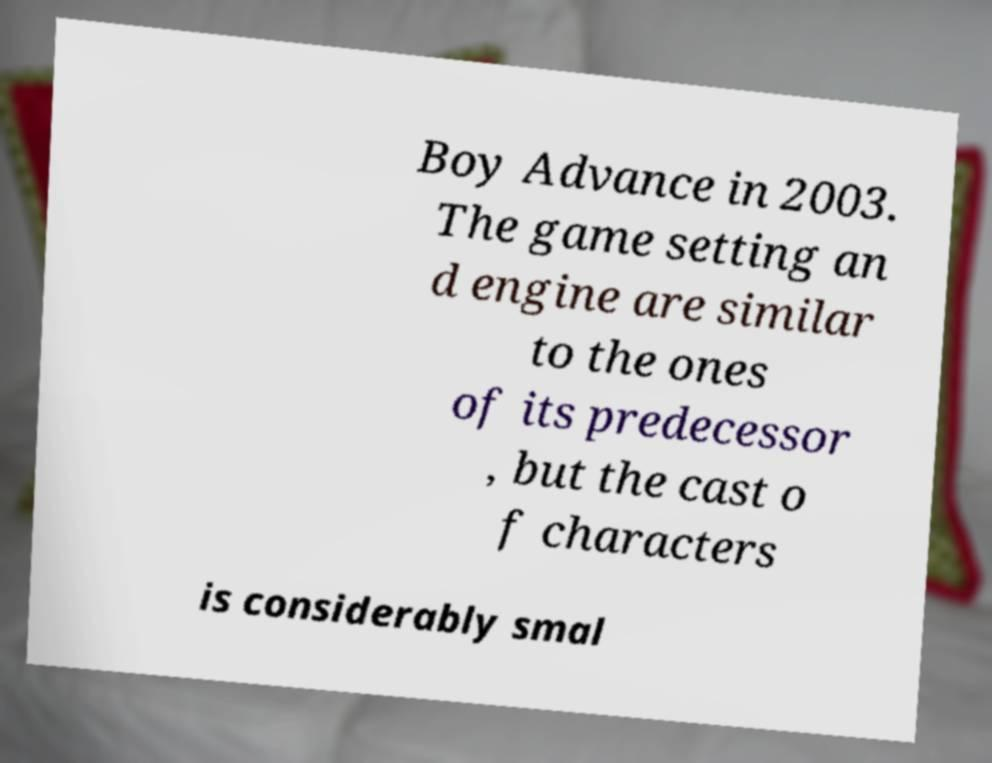Can you read and provide the text displayed in the image?This photo seems to have some interesting text. Can you extract and type it out for me? Boy Advance in 2003. The game setting an d engine are similar to the ones of its predecessor , but the cast o f characters is considerably smal 